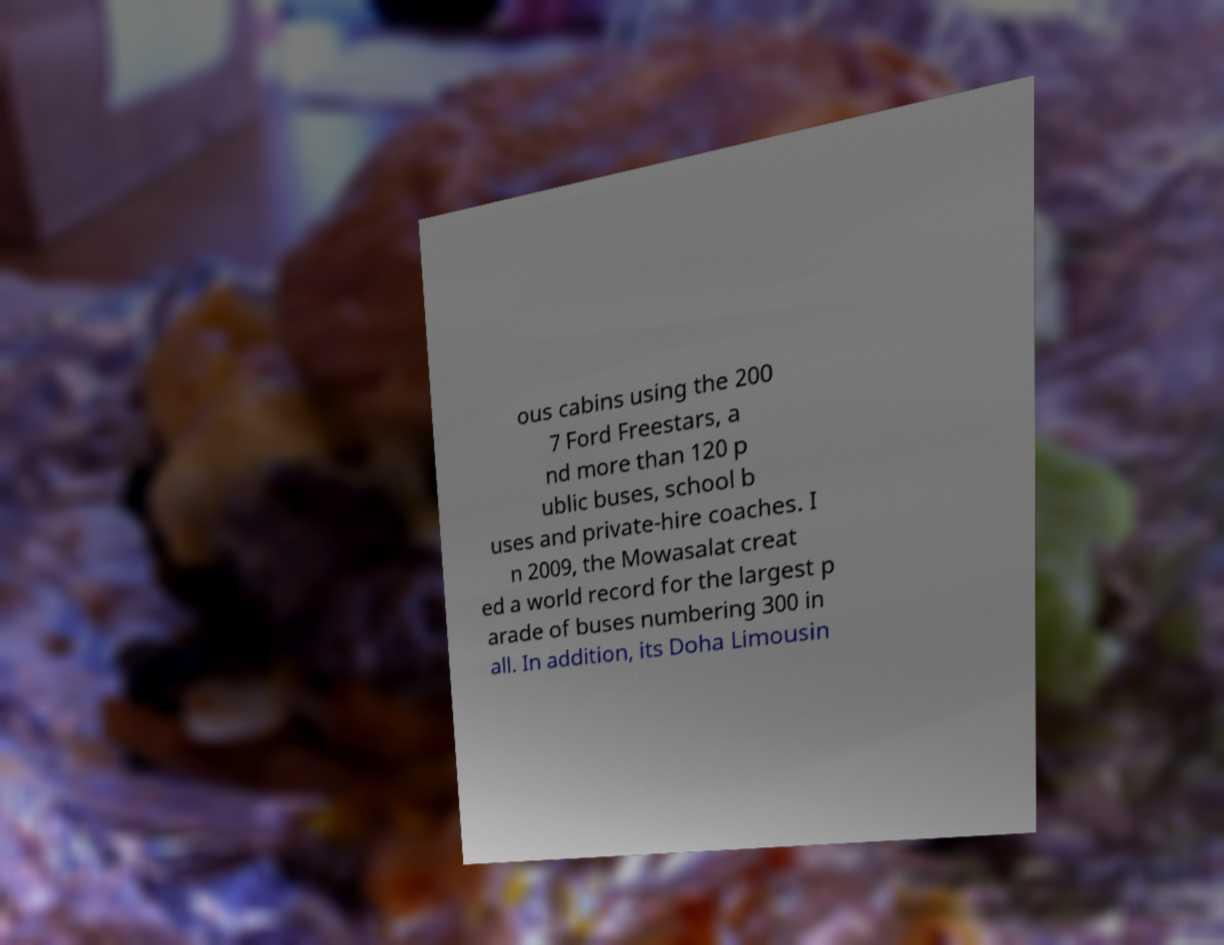Could you assist in decoding the text presented in this image and type it out clearly? ous cabins using the 200 7 Ford Freestars, a nd more than 120 p ublic buses, school b uses and private-hire coaches. I n 2009, the Mowasalat creat ed a world record for the largest p arade of buses numbering 300 in all. In addition, its Doha Limousin 